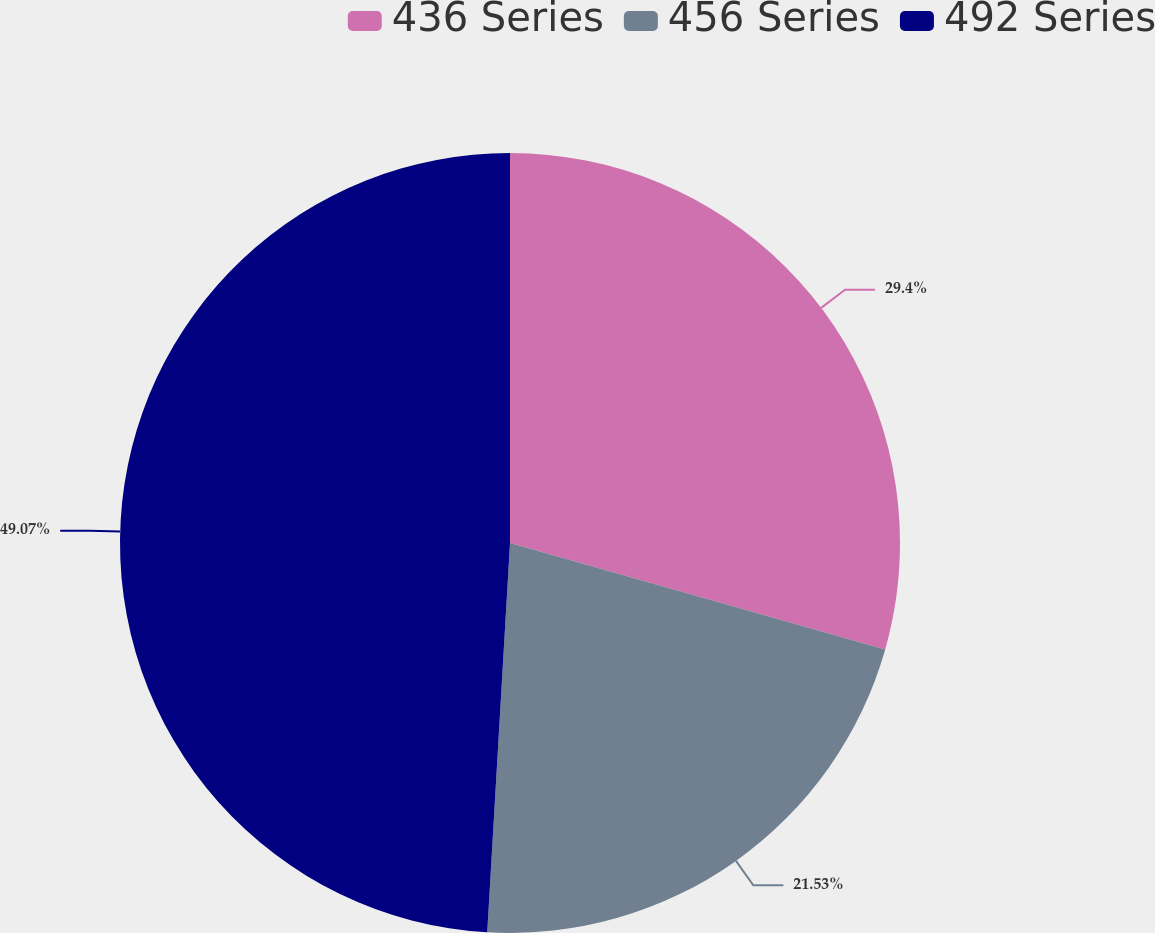Convert chart. <chart><loc_0><loc_0><loc_500><loc_500><pie_chart><fcel>436 Series<fcel>456 Series<fcel>492 Series<nl><fcel>29.4%<fcel>21.53%<fcel>49.07%<nl></chart> 